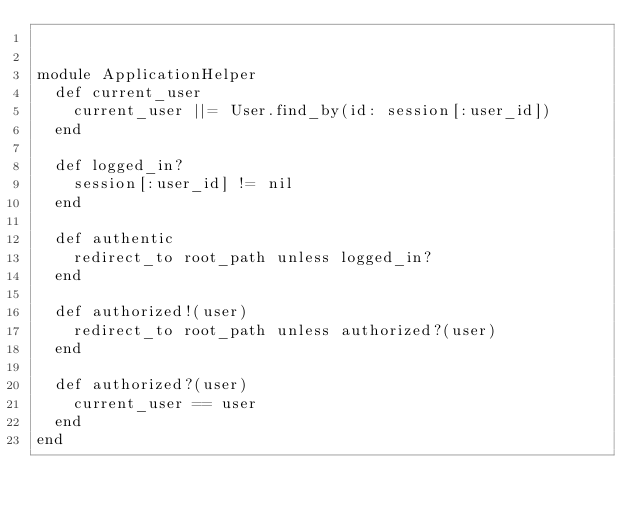<code> <loc_0><loc_0><loc_500><loc_500><_Ruby_>

module ApplicationHelper
  def current_user
    current_user ||= User.find_by(id: session[:user_id])
  end

  def logged_in?
    session[:user_id] != nil
  end

  def authentic
    redirect_to root_path unless logged_in?
  end

  def authorized!(user)
    redirect_to root_path unless authorized?(user)
  end

  def authorized?(user)
    current_user == user
  end
end
</code> 